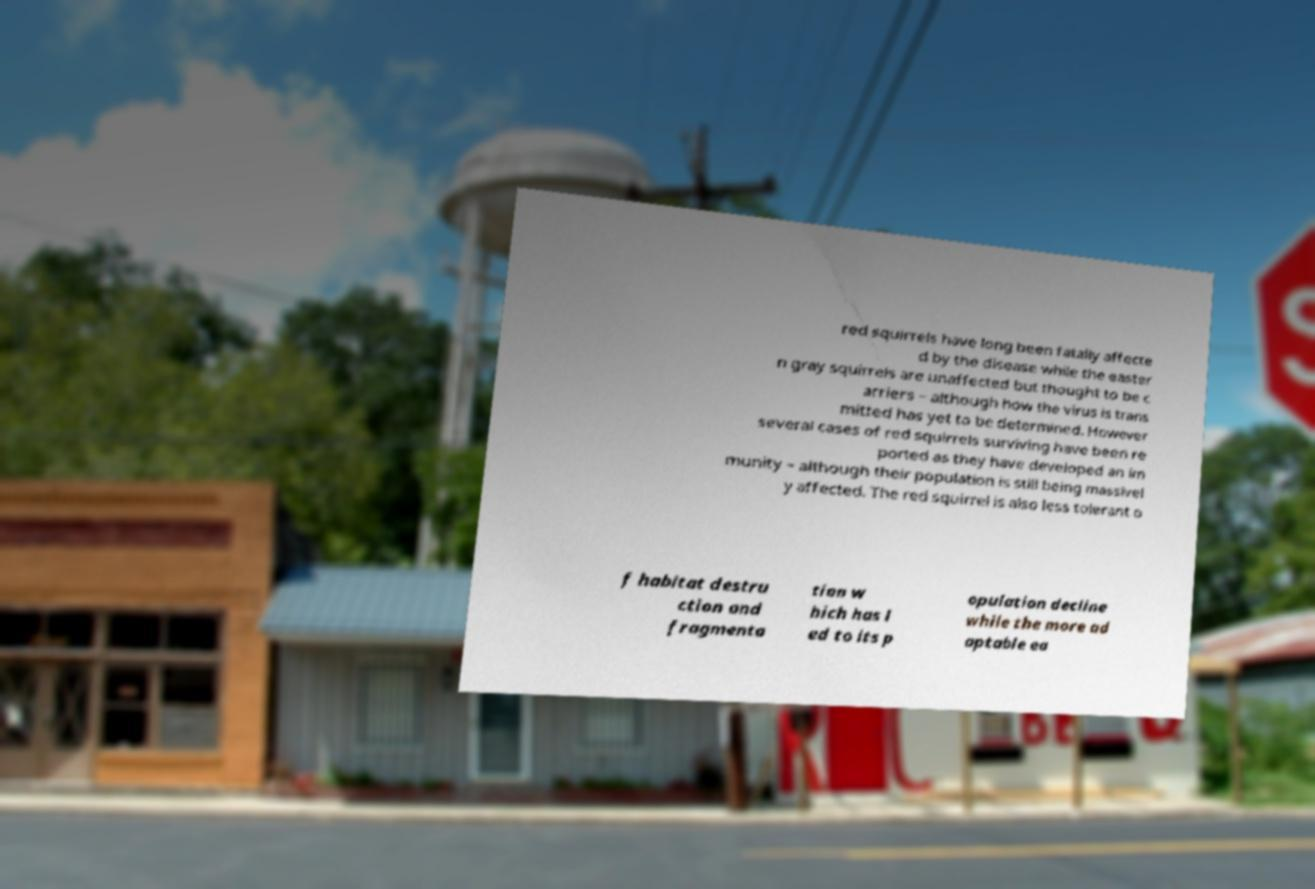Could you extract and type out the text from this image? red squirrels have long been fatally affecte d by the disease while the easter n gray squirrels are unaffected but thought to be c arriers – although how the virus is trans mitted has yet to be determined. However several cases of red squirrels surviving have been re ported as they have developed an im munity – although their population is still being massivel y affected. The red squirrel is also less tolerant o f habitat destru ction and fragmenta tion w hich has l ed to its p opulation decline while the more ad aptable ea 